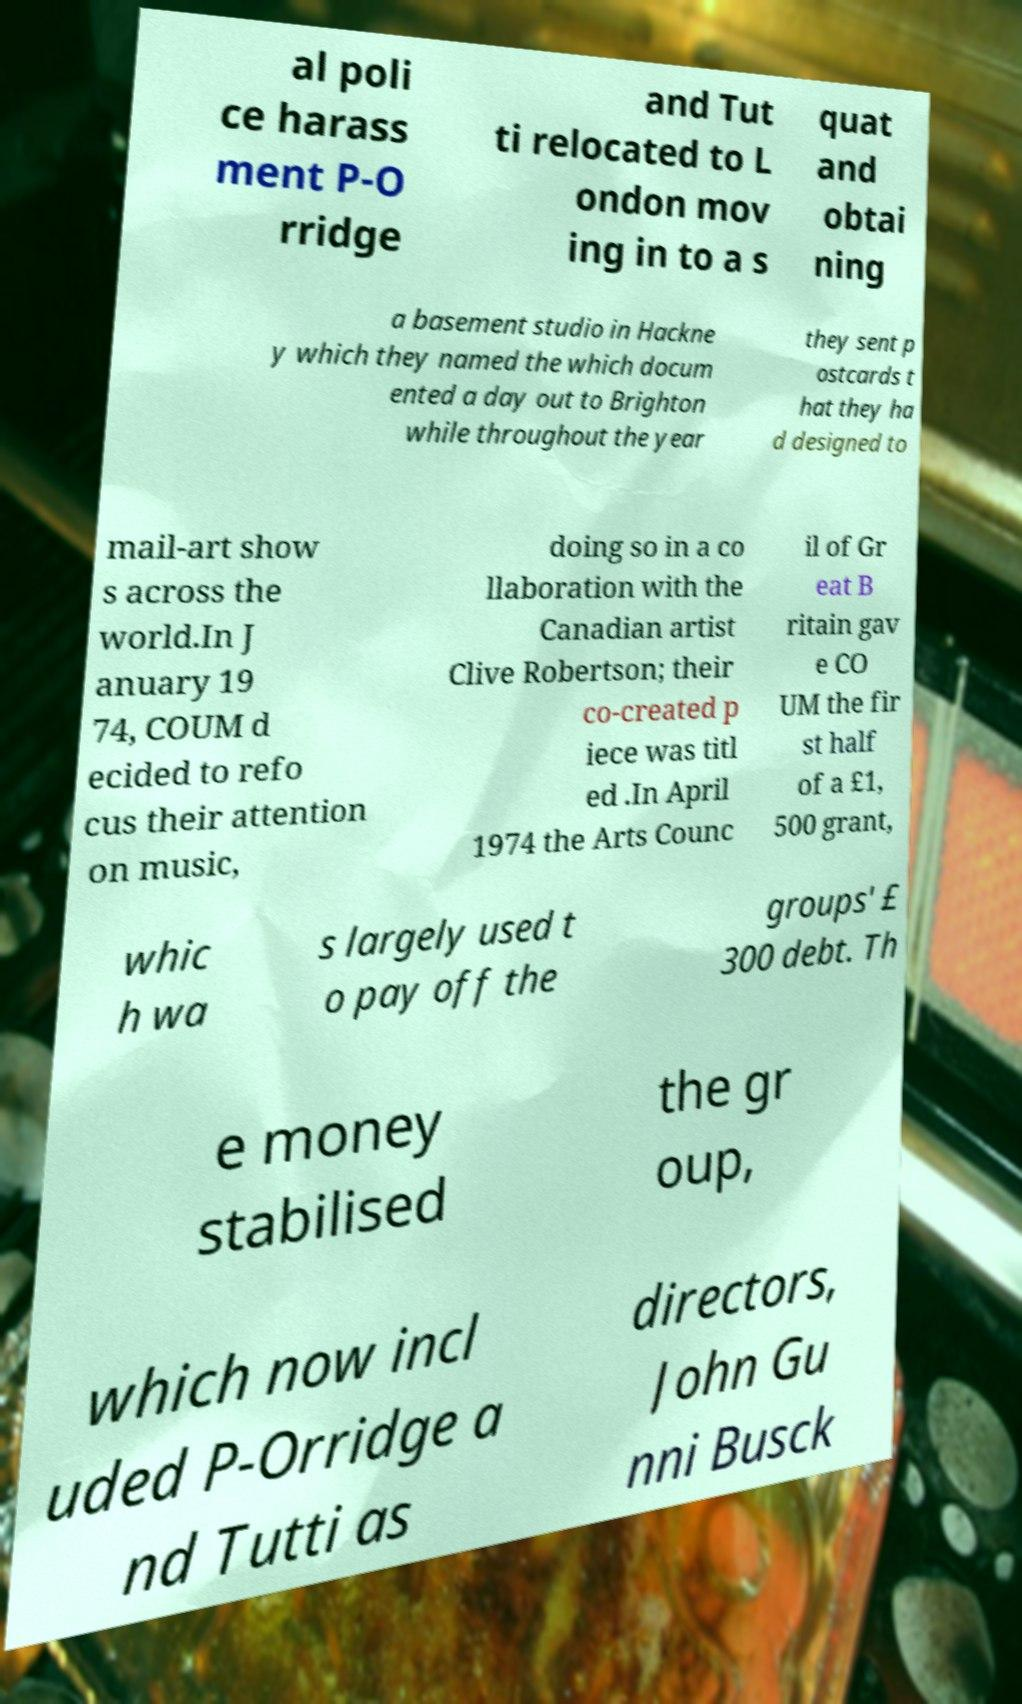There's text embedded in this image that I need extracted. Can you transcribe it verbatim? al poli ce harass ment P-O rridge and Tut ti relocated to L ondon mov ing in to a s quat and obtai ning a basement studio in Hackne y which they named the which docum ented a day out to Brighton while throughout the year they sent p ostcards t hat they ha d designed to mail-art show s across the world.In J anuary 19 74, COUM d ecided to refo cus their attention on music, doing so in a co llaboration with the Canadian artist Clive Robertson; their co-created p iece was titl ed .In April 1974 the Arts Counc il of Gr eat B ritain gav e CO UM the fir st half of a £1, 500 grant, whic h wa s largely used t o pay off the groups' £ 300 debt. Th e money stabilised the gr oup, which now incl uded P-Orridge a nd Tutti as directors, John Gu nni Busck 